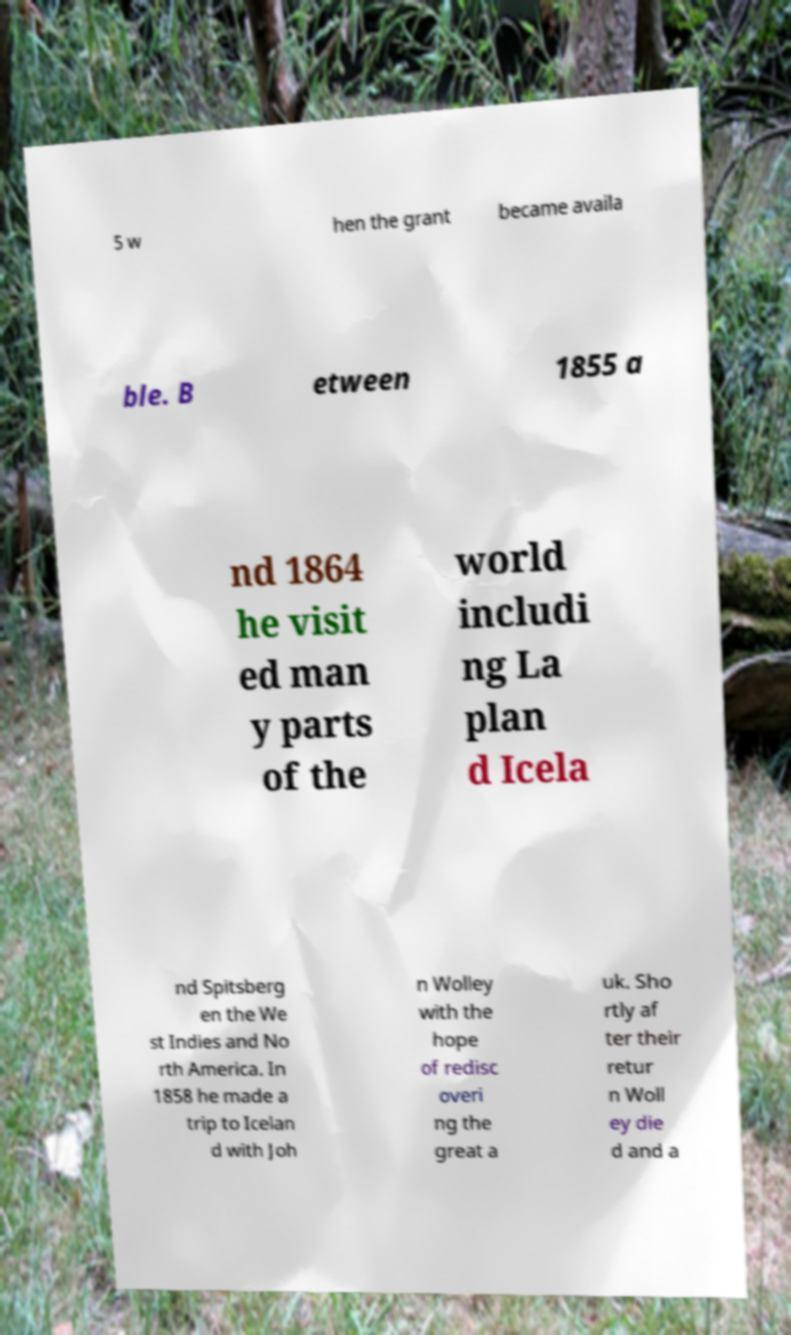For documentation purposes, I need the text within this image transcribed. Could you provide that? 5 w hen the grant became availa ble. B etween 1855 a nd 1864 he visit ed man y parts of the world includi ng La plan d Icela nd Spitsberg en the We st Indies and No rth America. In 1858 he made a trip to Icelan d with Joh n Wolley with the hope of redisc overi ng the great a uk. Sho rtly af ter their retur n Woll ey die d and a 